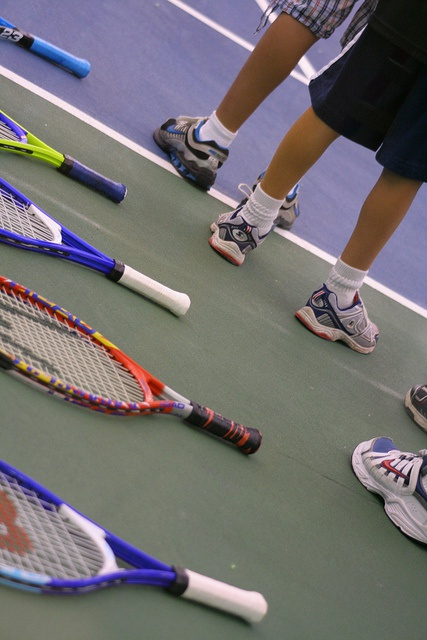Describe the objects in this image and their specific colors. I can see people in gray, black, maroon, and darkgray tones, tennis racket in gray, darkgray, lavender, and navy tones, tennis racket in gray, darkgray, black, and tan tones, people in gray, maroon, and black tones, and tennis racket in gray, lightgray, darkgray, and navy tones in this image. 